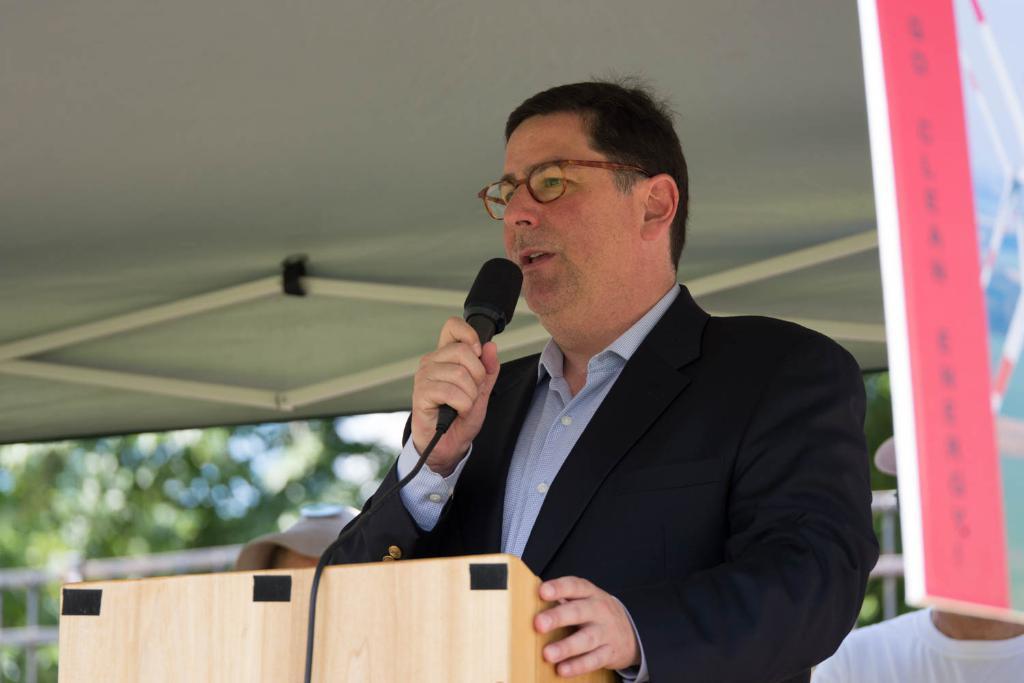Could you give a brief overview of what you see in this image? The person wearing black suit is standing and speaking in front of a mic and there is a wooden stand in front of him and there are two persons standing behind him. 